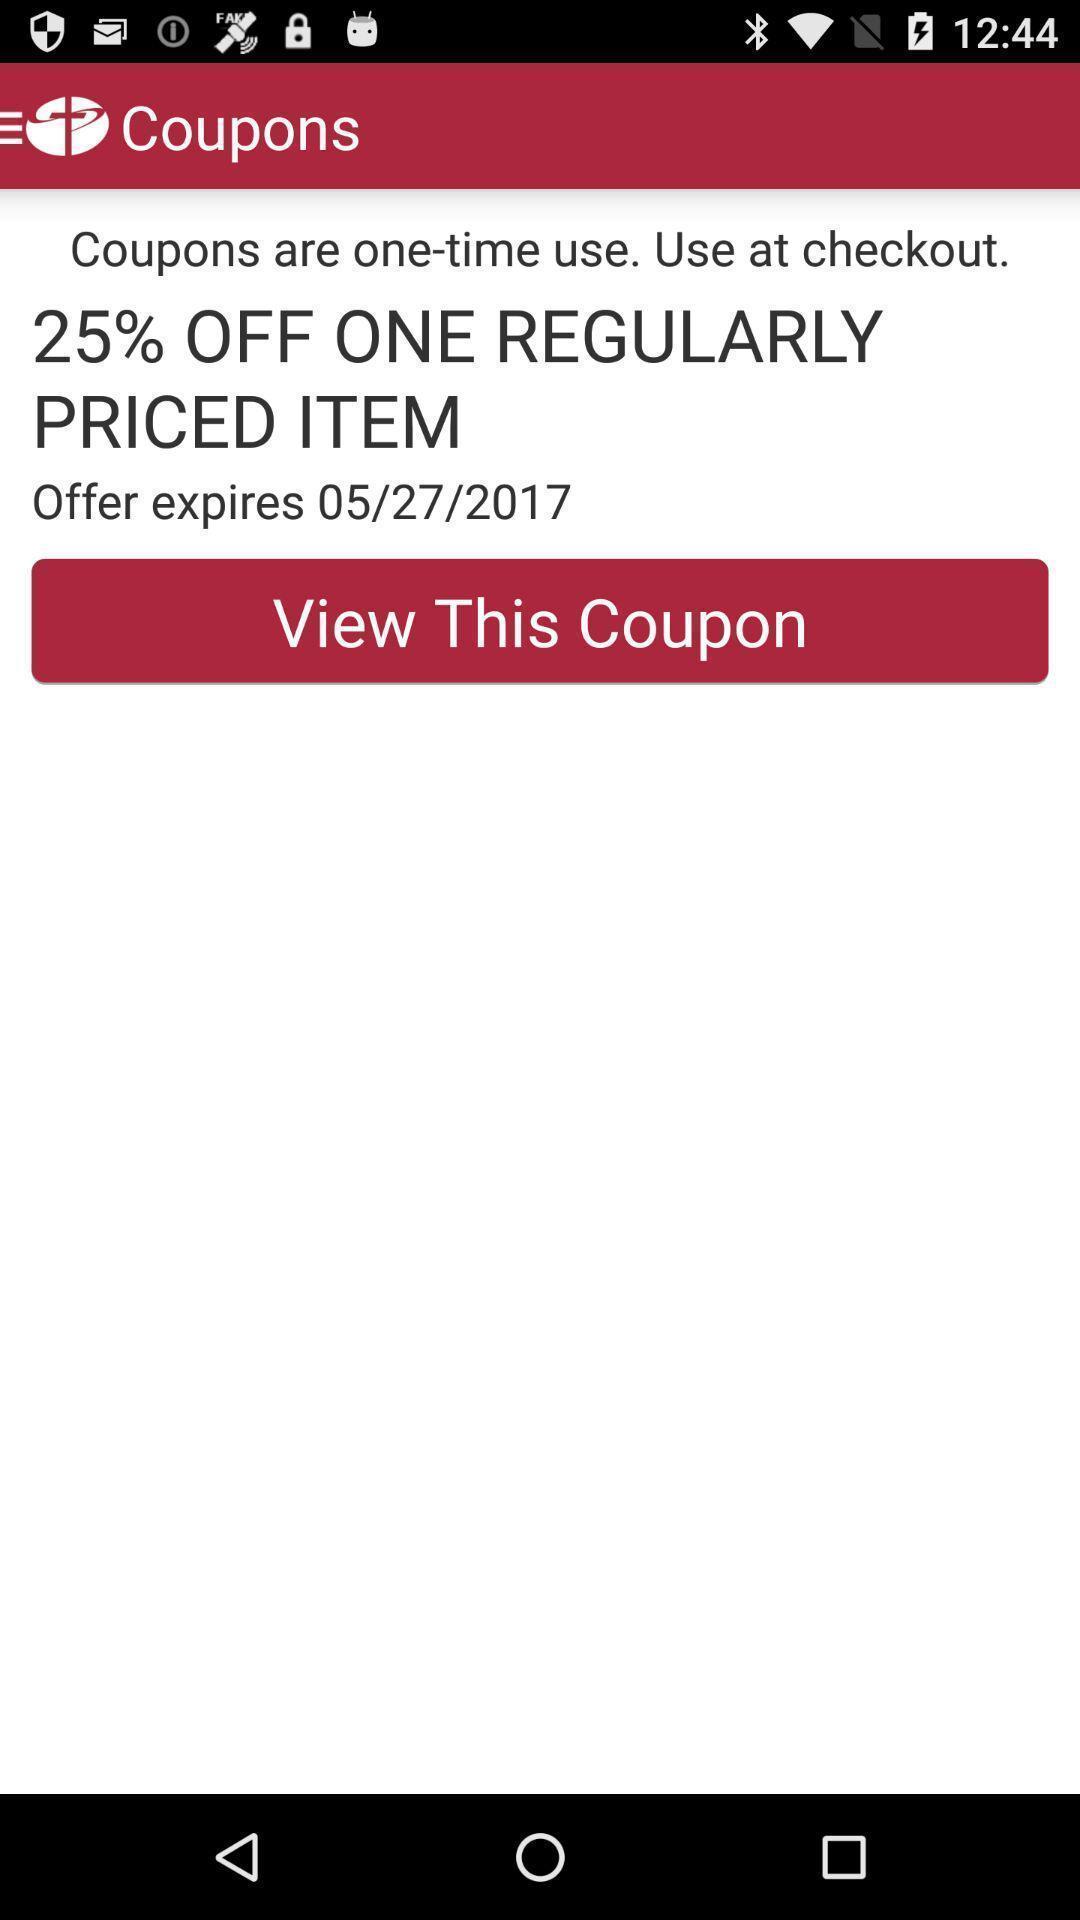Explain the elements present in this screenshot. Screen displaying the coupon details. 